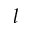Convert formula to latex. <formula><loc_0><loc_0><loc_500><loc_500>l</formula> 